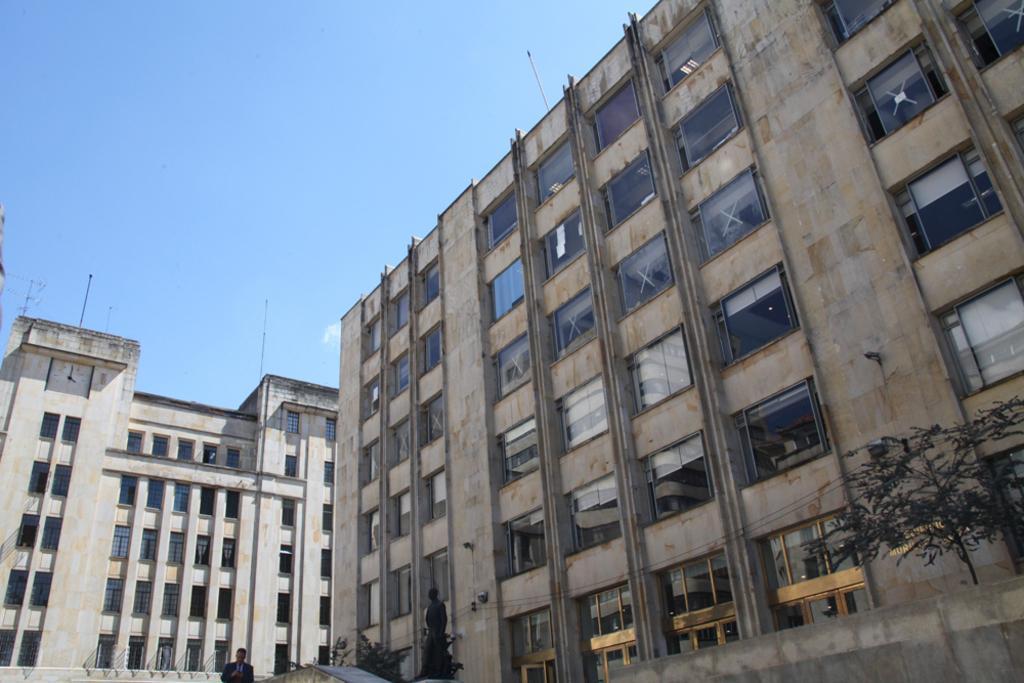Can you describe this image briefly? In this image, we can see few buildings with walls, pillars and glass windows. Here we can see few trees, sculpture. At the bottom, we can see a person in a suit. Top of the image, there is a sky and few poles. 